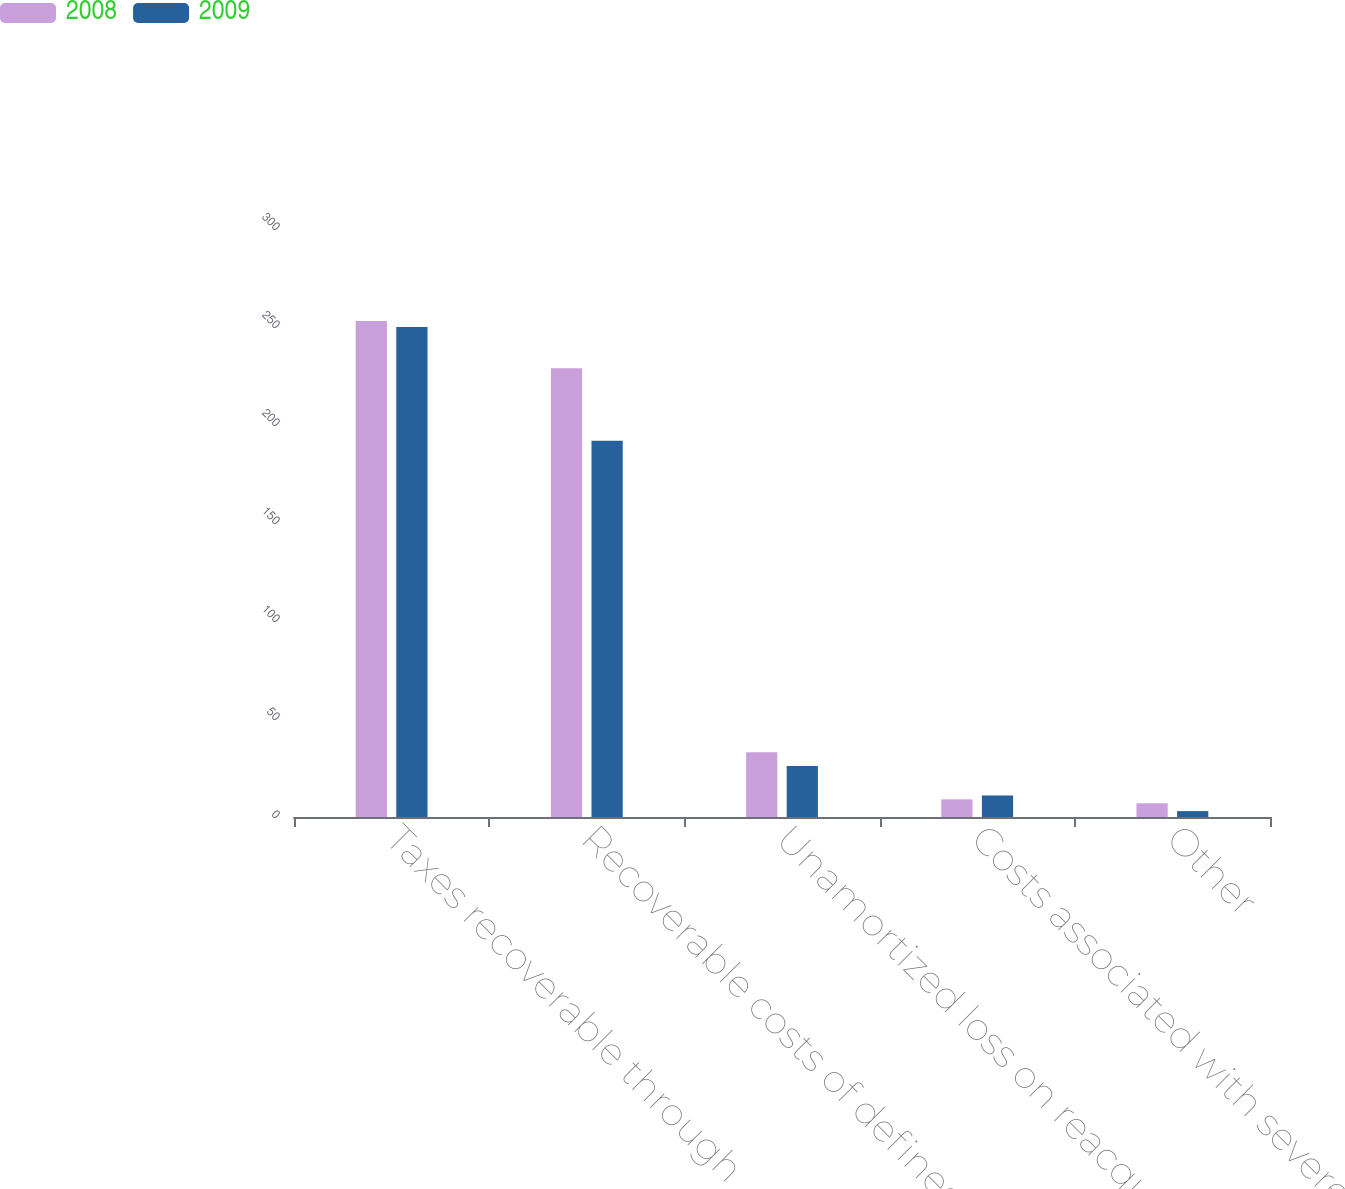Convert chart to OTSL. <chart><loc_0><loc_0><loc_500><loc_500><stacked_bar_chart><ecel><fcel>Taxes recoverable through<fcel>Recoverable costs of defined<fcel>Unamortized loss on reacquired<fcel>Costs associated with severe<fcel>Other<nl><fcel>2008<fcel>253<fcel>229<fcel>33<fcel>9<fcel>7<nl><fcel>2009<fcel>250<fcel>192<fcel>26<fcel>11<fcel>3<nl></chart> 